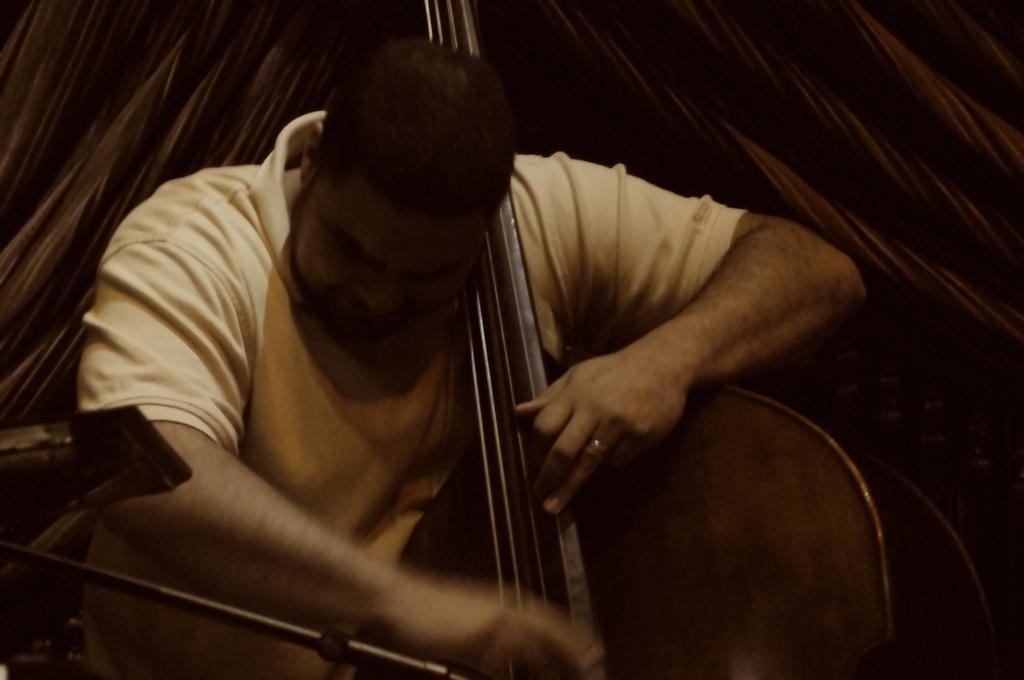In one or two sentences, can you explain what this image depicts? In this image I can see a person playing a musical instrument. In the background it is looking like a curtain. 